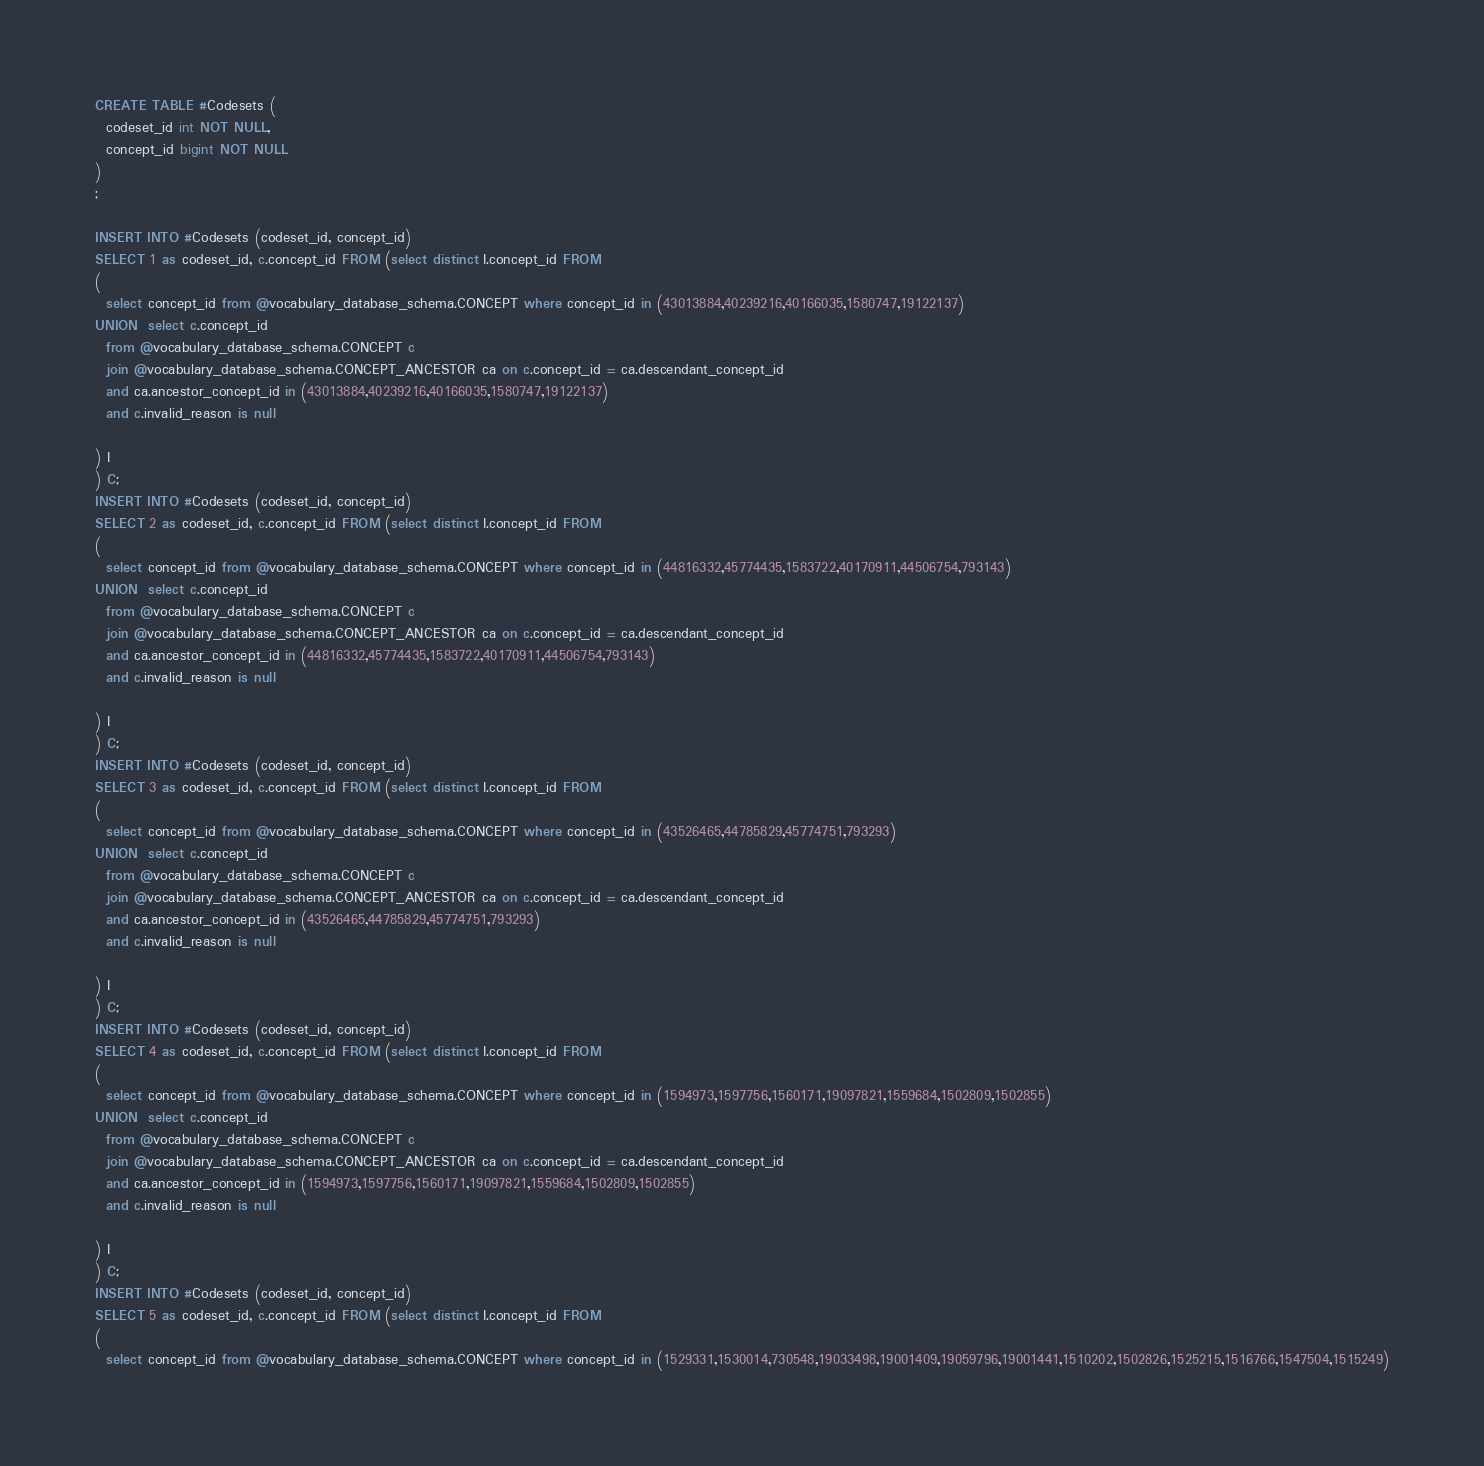<code> <loc_0><loc_0><loc_500><loc_500><_SQL_>CREATE TABLE #Codesets (
  codeset_id int NOT NULL,
  concept_id bigint NOT NULL
)
;

INSERT INTO #Codesets (codeset_id, concept_id)
SELECT 1 as codeset_id, c.concept_id FROM (select distinct I.concept_id FROM
( 
  select concept_id from @vocabulary_database_schema.CONCEPT where concept_id in (43013884,40239216,40166035,1580747,19122137)
UNION  select c.concept_id
  from @vocabulary_database_schema.CONCEPT c
  join @vocabulary_database_schema.CONCEPT_ANCESTOR ca on c.concept_id = ca.descendant_concept_id
  and ca.ancestor_concept_id in (43013884,40239216,40166035,1580747,19122137)
  and c.invalid_reason is null

) I
) C;
INSERT INTO #Codesets (codeset_id, concept_id)
SELECT 2 as codeset_id, c.concept_id FROM (select distinct I.concept_id FROM
( 
  select concept_id from @vocabulary_database_schema.CONCEPT where concept_id in (44816332,45774435,1583722,40170911,44506754,793143)
UNION  select c.concept_id
  from @vocabulary_database_schema.CONCEPT c
  join @vocabulary_database_schema.CONCEPT_ANCESTOR ca on c.concept_id = ca.descendant_concept_id
  and ca.ancestor_concept_id in (44816332,45774435,1583722,40170911,44506754,793143)
  and c.invalid_reason is null

) I
) C;
INSERT INTO #Codesets (codeset_id, concept_id)
SELECT 3 as codeset_id, c.concept_id FROM (select distinct I.concept_id FROM
( 
  select concept_id from @vocabulary_database_schema.CONCEPT where concept_id in (43526465,44785829,45774751,793293)
UNION  select c.concept_id
  from @vocabulary_database_schema.CONCEPT c
  join @vocabulary_database_schema.CONCEPT_ANCESTOR ca on c.concept_id = ca.descendant_concept_id
  and ca.ancestor_concept_id in (43526465,44785829,45774751,793293)
  and c.invalid_reason is null

) I
) C;
INSERT INTO #Codesets (codeset_id, concept_id)
SELECT 4 as codeset_id, c.concept_id FROM (select distinct I.concept_id FROM
( 
  select concept_id from @vocabulary_database_schema.CONCEPT where concept_id in (1594973,1597756,1560171,19097821,1559684,1502809,1502855)
UNION  select c.concept_id
  from @vocabulary_database_schema.CONCEPT c
  join @vocabulary_database_schema.CONCEPT_ANCESTOR ca on c.concept_id = ca.descendant_concept_id
  and ca.ancestor_concept_id in (1594973,1597756,1560171,19097821,1559684,1502809,1502855)
  and c.invalid_reason is null

) I
) C;
INSERT INTO #Codesets (codeset_id, concept_id)
SELECT 5 as codeset_id, c.concept_id FROM (select distinct I.concept_id FROM
( 
  select concept_id from @vocabulary_database_schema.CONCEPT where concept_id in (1529331,1530014,730548,19033498,19001409,19059796,19001441,1510202,1502826,1525215,1516766,1547504,1515249)</code> 